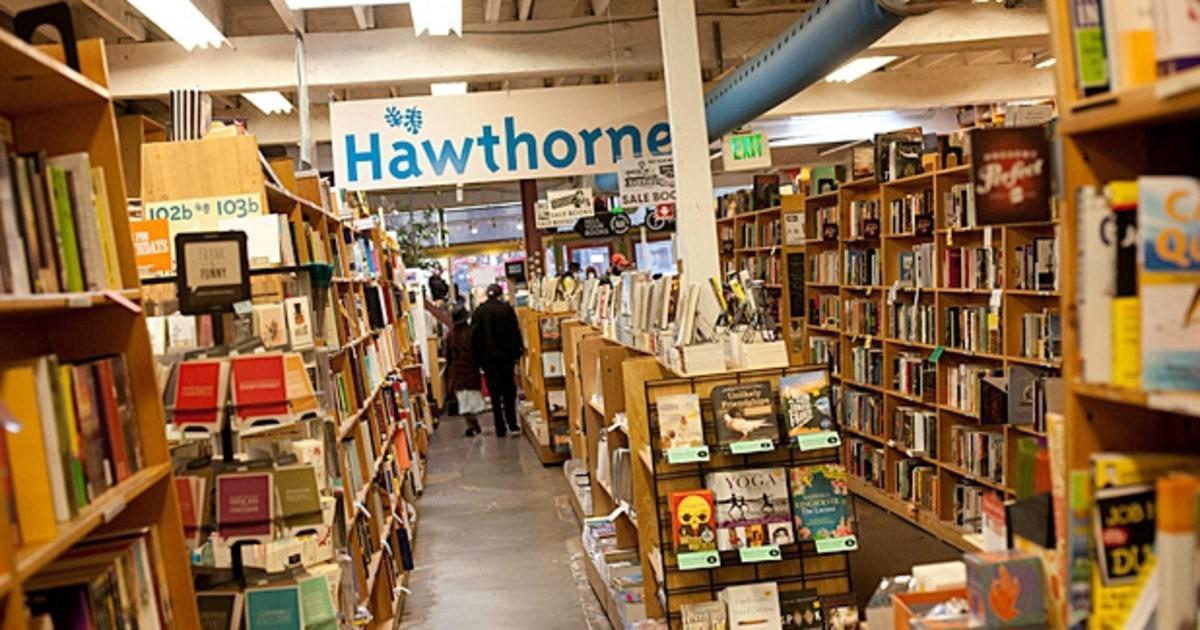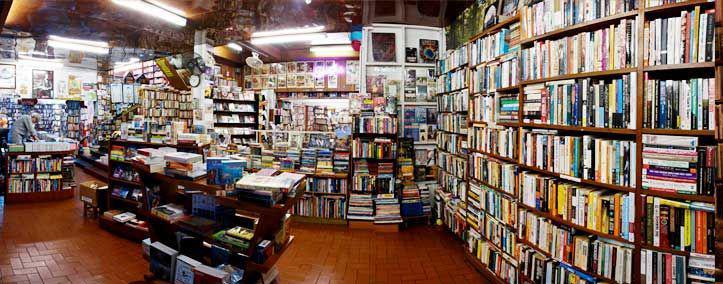The first image is the image on the left, the second image is the image on the right. Assess this claim about the two images: "One person is browsing at the bookshelf on the right side.". Correct or not? Answer yes or no. No. The first image is the image on the left, the second image is the image on the right. Considering the images on both sides, is "In one image, a long gray pipe runs the length of the bookstore ceiling." valid? Answer yes or no. Yes. 